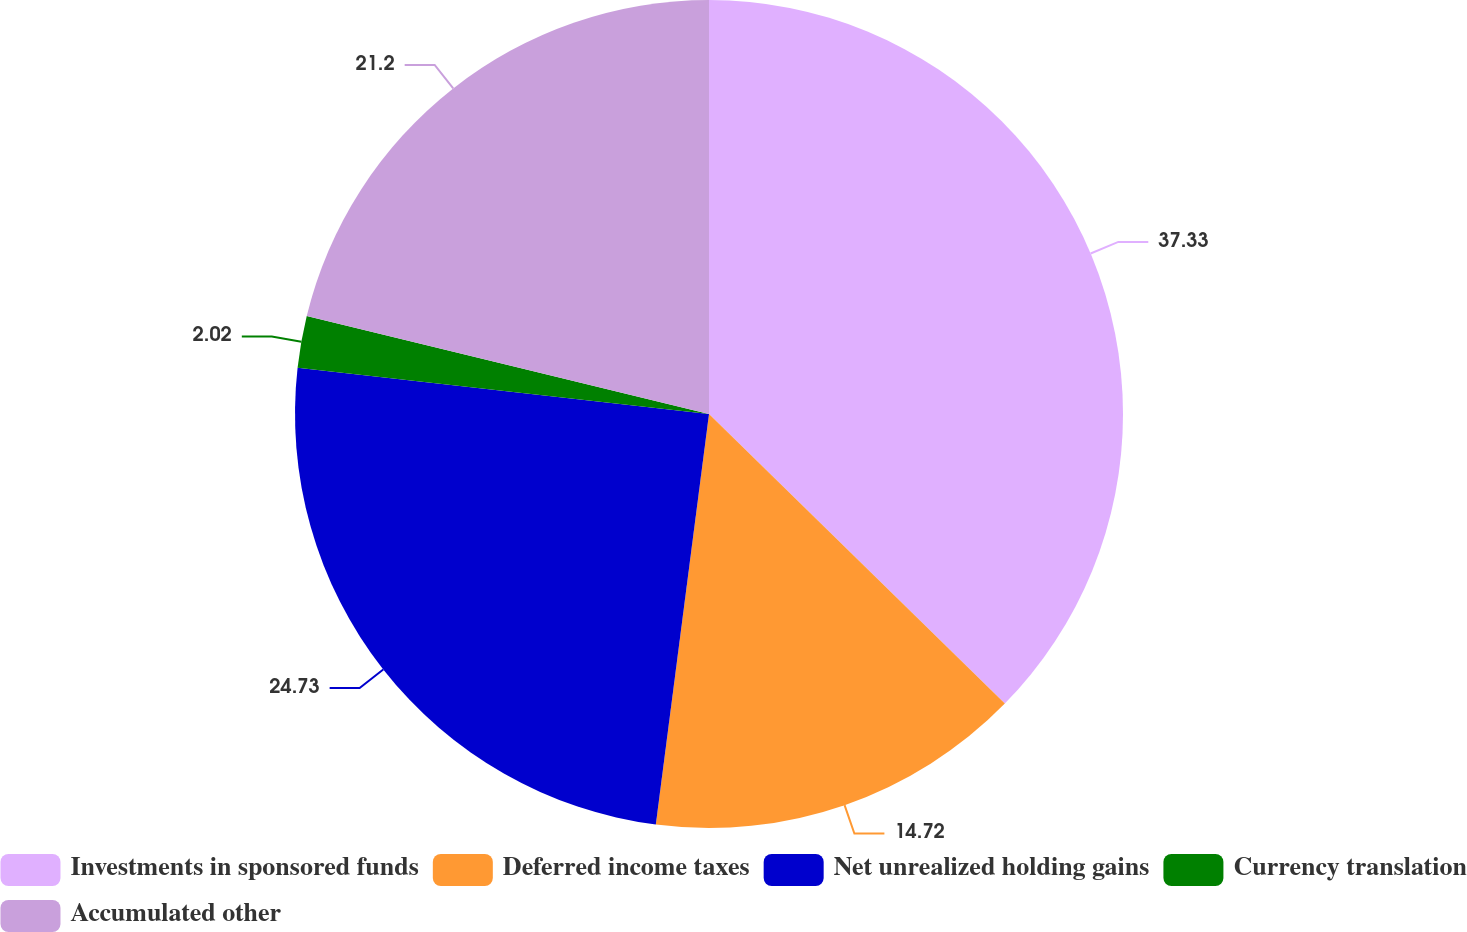<chart> <loc_0><loc_0><loc_500><loc_500><pie_chart><fcel>Investments in sponsored funds<fcel>Deferred income taxes<fcel>Net unrealized holding gains<fcel>Currency translation<fcel>Accumulated other<nl><fcel>37.33%<fcel>14.72%<fcel>24.73%<fcel>2.02%<fcel>21.2%<nl></chart> 